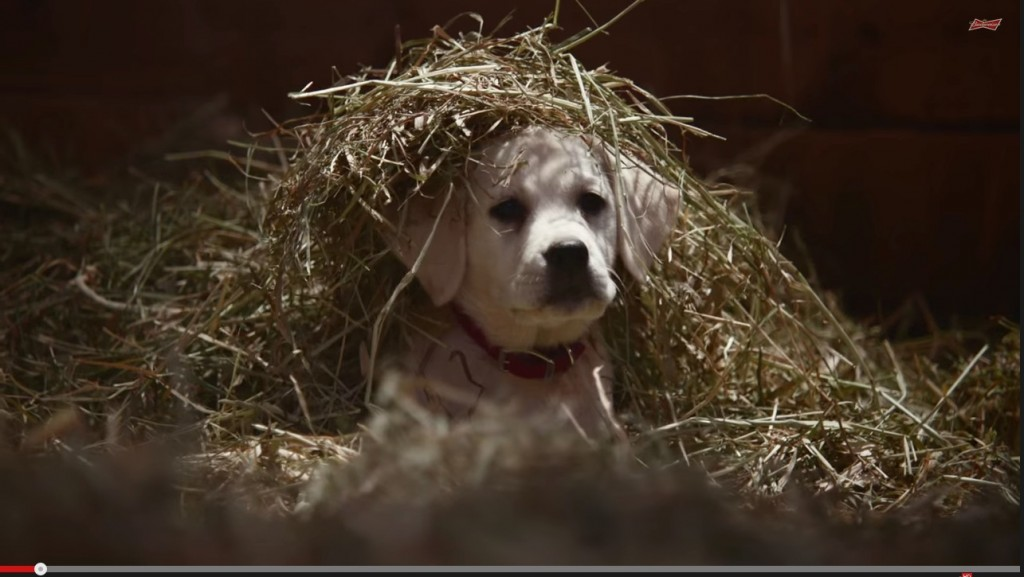Could the way the hay is positioned on the puppy's head suggest human interaction, or is it more likely the result of the puppy's own movements? The hay appears to be deliberately placed on the puppy's head, as it forms a neat and intentional shape resembling a hat or crown. Such an orderly arrangement is unlikely to occur purely by chance through the puppy's movements. Additionally, the puppy's calm demeanor further supports the idea that it might be accustomed to human interaction, making it more probable that a person gently placed the hay on its head for playful or aesthetic purposes. 